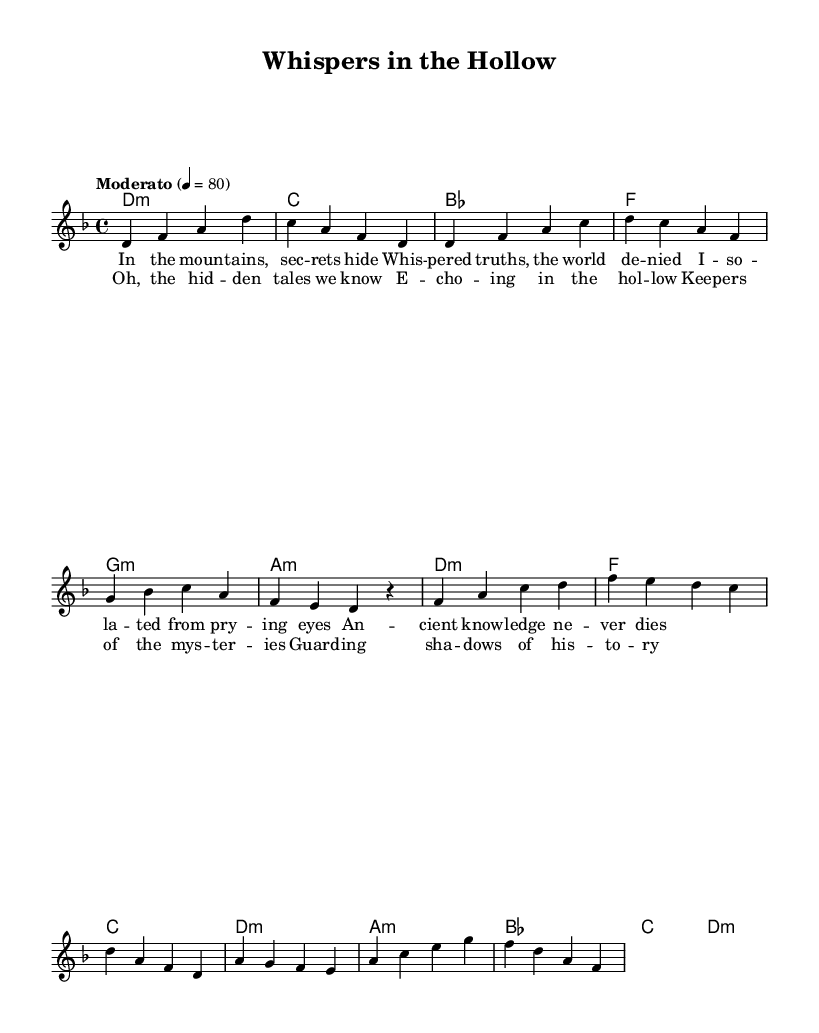What is the key signature of this music? The music is in D minor, indicated by the key signature which has one flat (B flat).
Answer: D minor What is the time signature of this piece? The time signature is found at the beginning of the score, marked by the fraction 4/4.
Answer: 4/4 What is the tempo marking of the piece? The tempo marking indicates the speed of the piece, which is noted as "Moderato" and a metronome marking of 4 = 80.
Answer: Moderato How many measures are in the verse section? By counting the measures in the verse part of the melody, we can tally a total of four measures.
Answer: Four measures What is the first lyric line of the chorus? The lyrics in the chorus start with "Oh, the hid -- den tales we know," as specified under the chorus section.
Answer: Oh, the hid -- den tales we know What harmony is used in the chorus for the first measure? The first measure of the chorus is marked with the chord F major, indicated by the chord symbol above the staff.
Answer: F What theme is predominant in the lyrics of this piece? The lyrics explore themes of secrecy and hidden knowledge, reflecting feelings of isolation.
Answer: Secrecy and hidden knowledge 